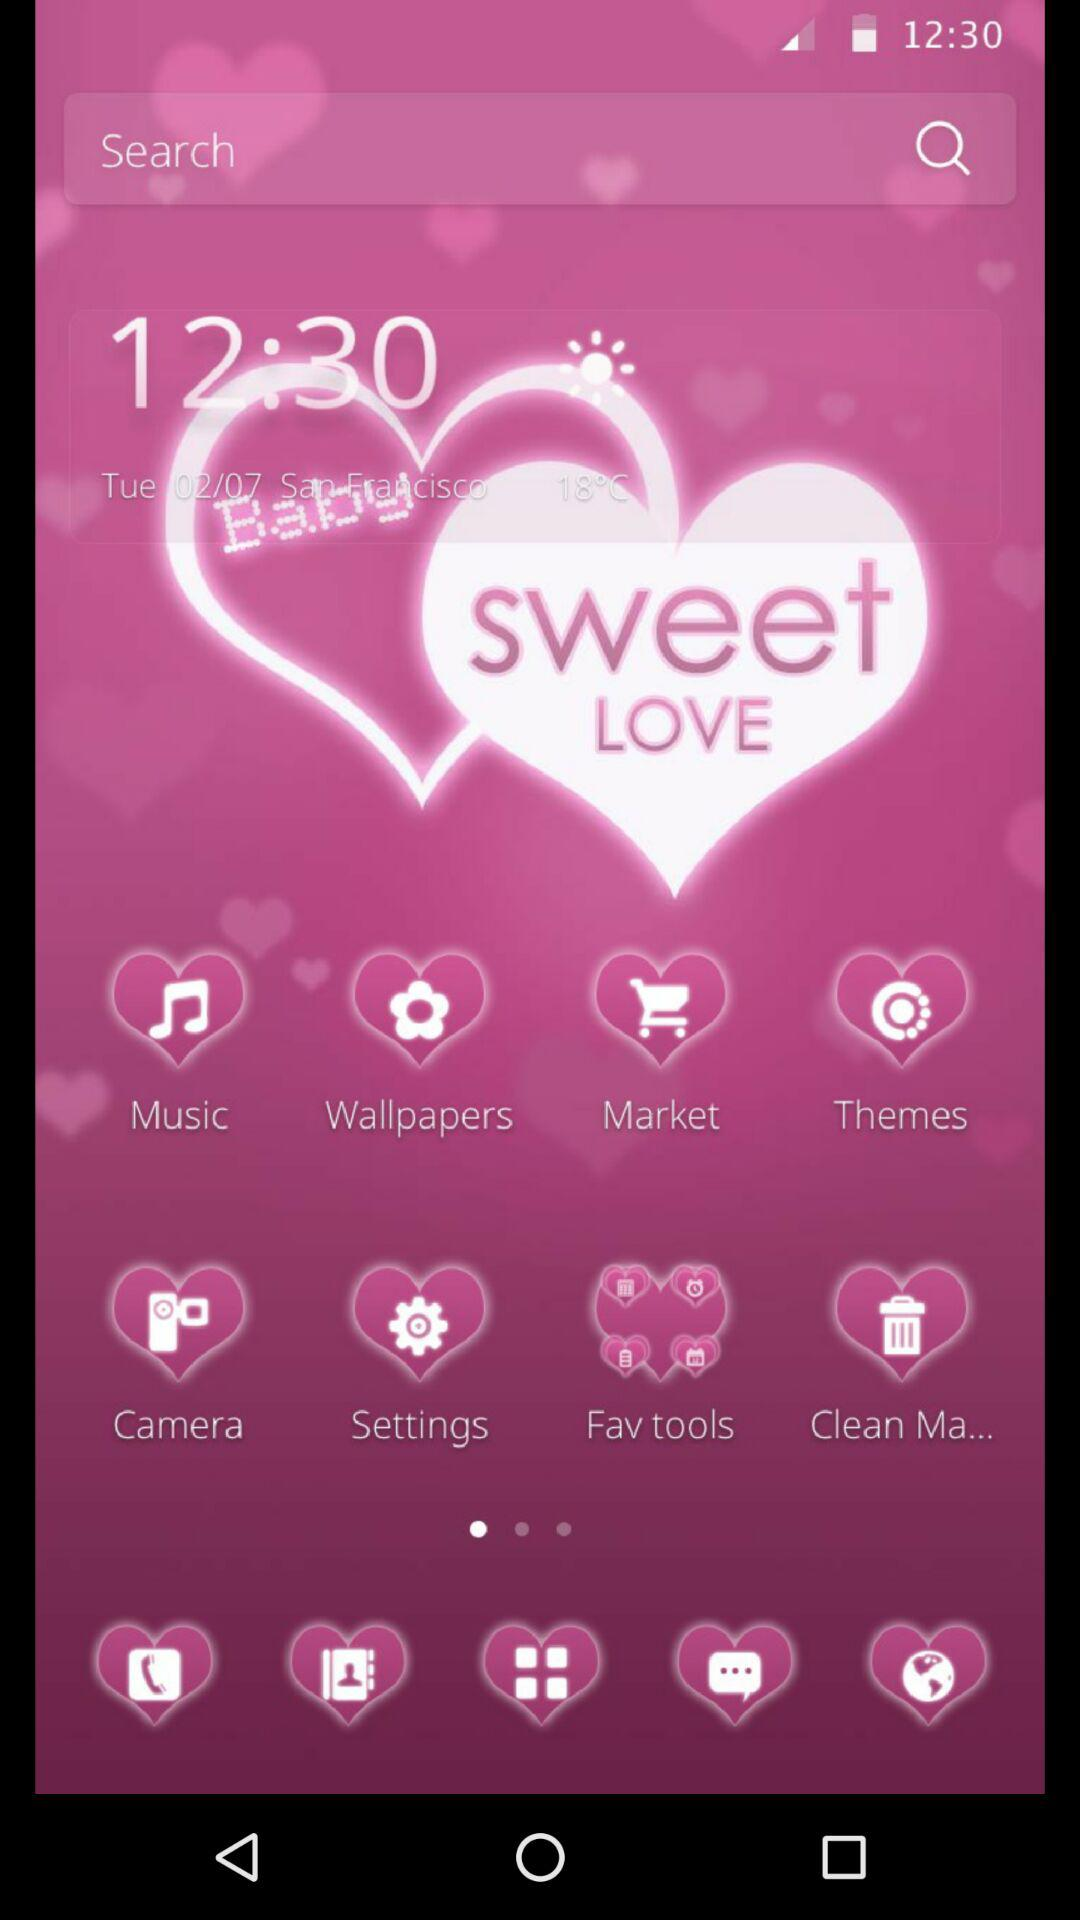What is the day? The day is Tuesday. 